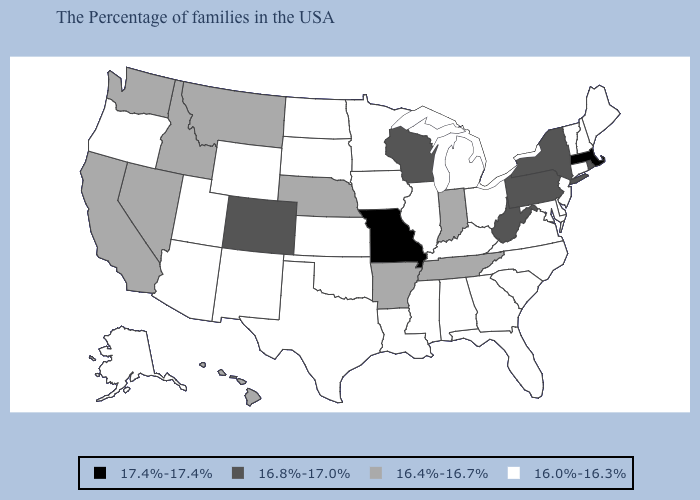What is the value of Oklahoma?
Quick response, please. 16.0%-16.3%. Does New Jersey have the lowest value in the Northeast?
Keep it brief. Yes. How many symbols are there in the legend?
Write a very short answer. 4. Does Montana have the same value as Wyoming?
Concise answer only. No. Name the states that have a value in the range 17.4%-17.4%?
Quick response, please. Massachusetts, Missouri. Which states have the lowest value in the USA?
Short answer required. Maine, New Hampshire, Vermont, Connecticut, New Jersey, Delaware, Maryland, Virginia, North Carolina, South Carolina, Ohio, Florida, Georgia, Michigan, Kentucky, Alabama, Illinois, Mississippi, Louisiana, Minnesota, Iowa, Kansas, Oklahoma, Texas, South Dakota, North Dakota, Wyoming, New Mexico, Utah, Arizona, Oregon, Alaska. What is the value of Missouri?
Write a very short answer. 17.4%-17.4%. Name the states that have a value in the range 17.4%-17.4%?
Give a very brief answer. Massachusetts, Missouri. Among the states that border Indiana , which have the lowest value?
Concise answer only. Ohio, Michigan, Kentucky, Illinois. What is the value of Nebraska?
Concise answer only. 16.4%-16.7%. Is the legend a continuous bar?
Concise answer only. No. What is the highest value in the USA?
Keep it brief. 17.4%-17.4%. What is the highest value in the Northeast ?
Keep it brief. 17.4%-17.4%. Does Iowa have the same value as Connecticut?
Answer briefly. Yes. 